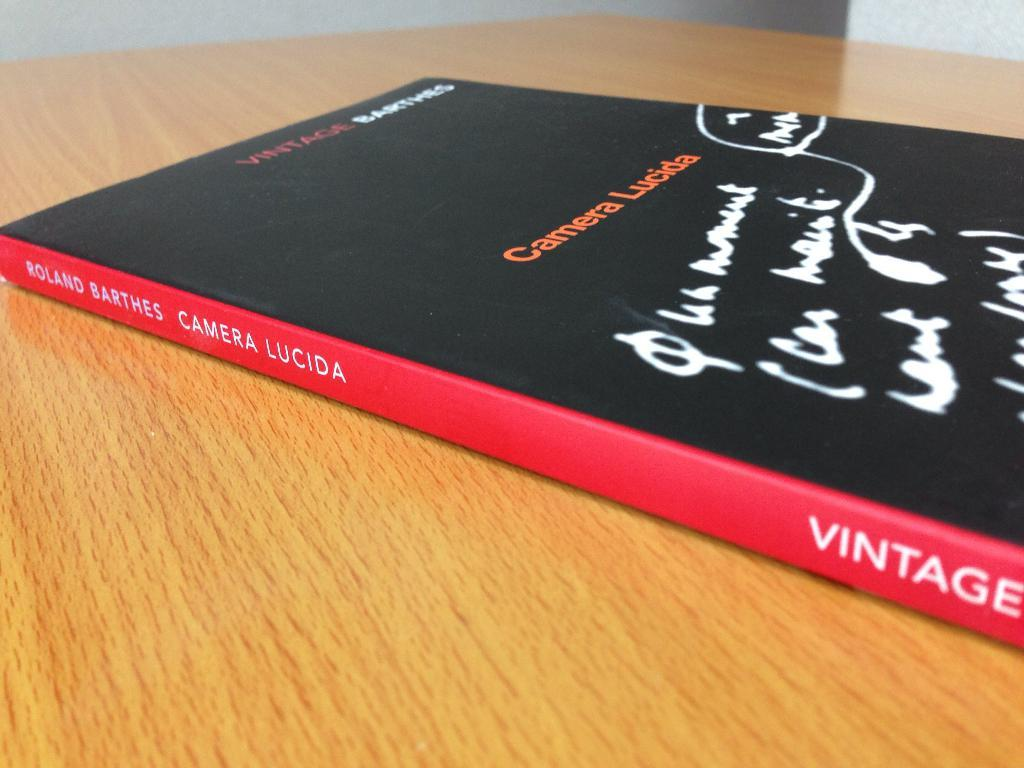<image>
Provide a brief description of the given image. A book titled Camera Lucida is on a table. 